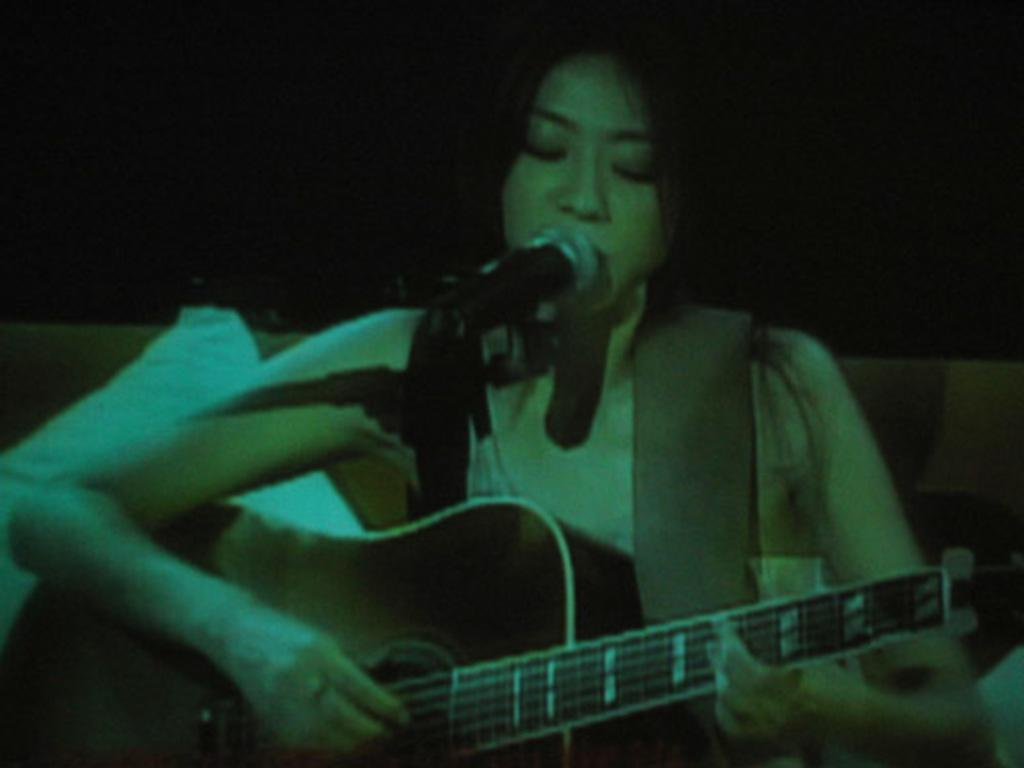What is the woman doing in the image? The woman is sitting on a couch in the image. What object is the woman holding? The woman is holding a guitar. What is in front of the woman? There is a microphone in front of the woman. What can be seen in the background of the image? There is a wall in the background of the image. What type of stone is the woman touching in the image? There is no stone present in the image; the woman is holding a guitar and sitting on a couch. 